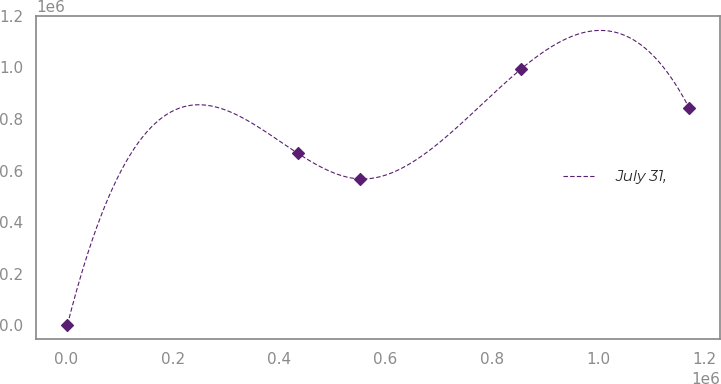<chart> <loc_0><loc_0><loc_500><loc_500><line_chart><ecel><fcel>July 31,<nl><fcel>2141.75<fcel>2100.78<nl><fcel>435583<fcel>666415<nl><fcel>552549<fcel>567318<nl><fcel>854902<fcel>993070<nl><fcel>1.1718e+06<fcel>841870<nl></chart> 